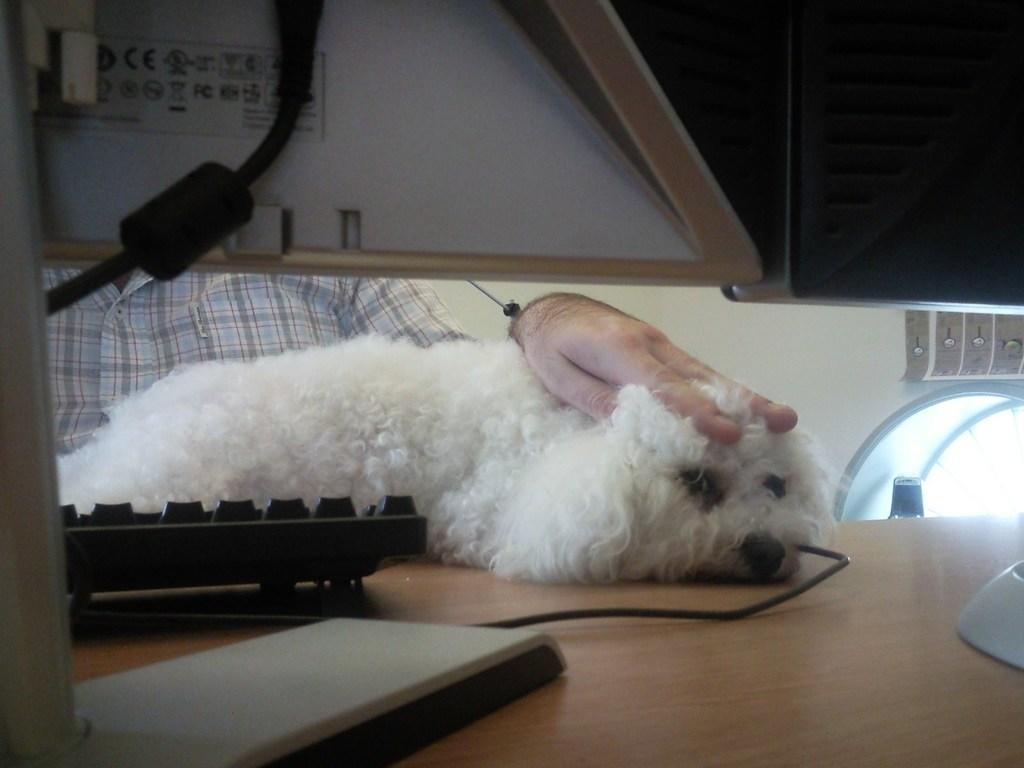What electronic device is visible in the image? There is a monitor in the image. What is used for input with the monitor? There is a keyboard in the image. What connects the monitor and keyboard? There is a cable in the image. What animal is on the table in the image? There is a dog on the table in the image. Who is present in the image? There is a person sitting in the image. What can be seen behind the person? There is a wall in the background of the image. What song is the person singing in the image? There is no indication in the image that the person is singing, so it cannot be determined which song they might be singing. 